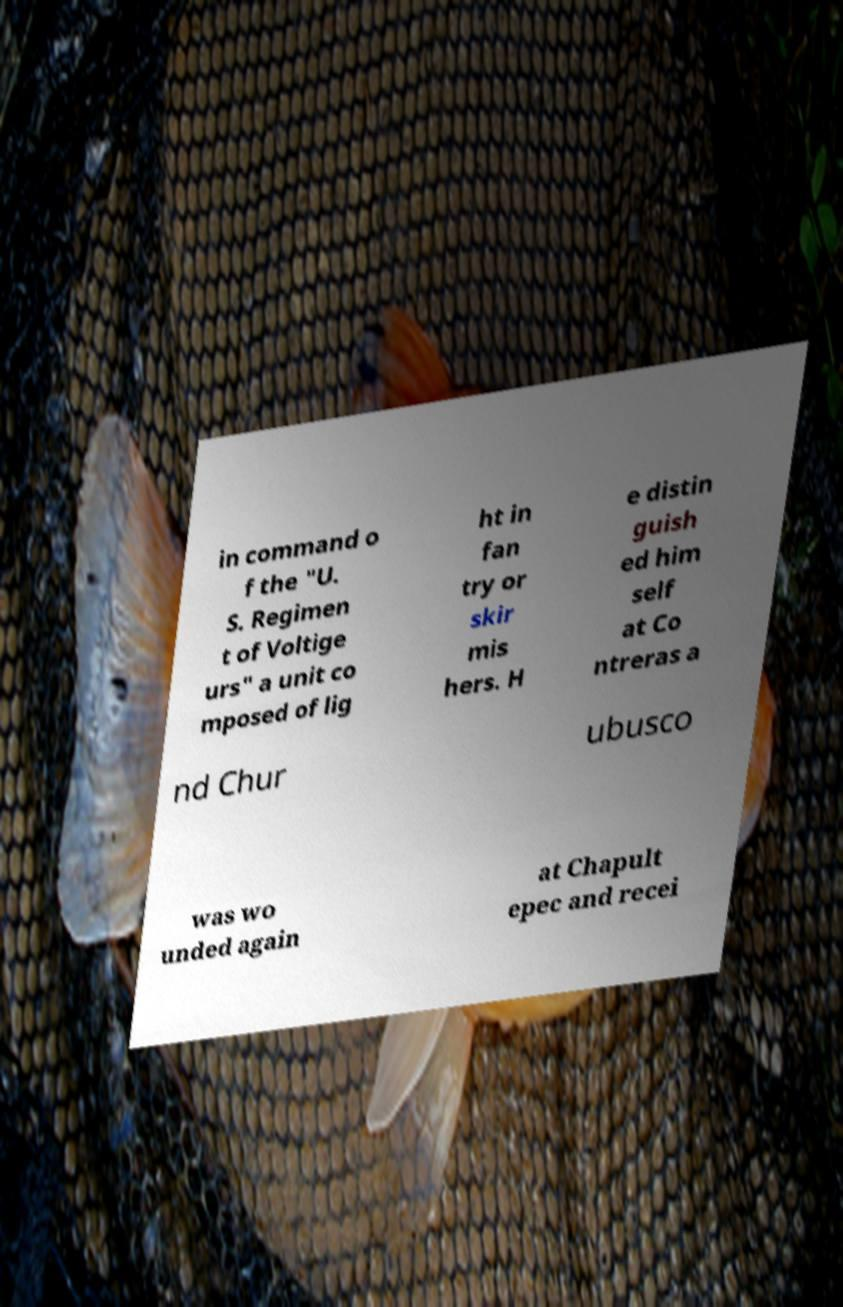Could you assist in decoding the text presented in this image and type it out clearly? in command o f the "U. S. Regimen t of Voltige urs" a unit co mposed of lig ht in fan try or skir mis hers. H e distin guish ed him self at Co ntreras a nd Chur ubusco was wo unded again at Chapult epec and recei 